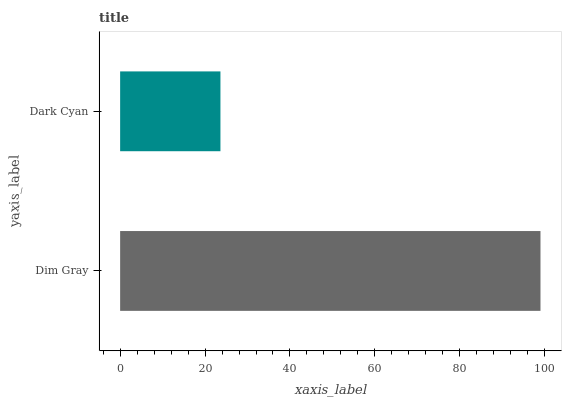Is Dark Cyan the minimum?
Answer yes or no. Yes. Is Dim Gray the maximum?
Answer yes or no. Yes. Is Dark Cyan the maximum?
Answer yes or no. No. Is Dim Gray greater than Dark Cyan?
Answer yes or no. Yes. Is Dark Cyan less than Dim Gray?
Answer yes or no. Yes. Is Dark Cyan greater than Dim Gray?
Answer yes or no. No. Is Dim Gray less than Dark Cyan?
Answer yes or no. No. Is Dim Gray the high median?
Answer yes or no. Yes. Is Dark Cyan the low median?
Answer yes or no. Yes. Is Dark Cyan the high median?
Answer yes or no. No. Is Dim Gray the low median?
Answer yes or no. No. 